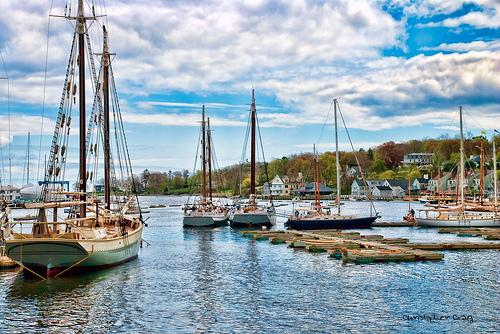Analyze the sentiment evoked by the image, based on the objects and settings in it. The image evokes a sense of peacefulness and tranquility, with calm water in the harbor, boats gently floating or docked, and picturesque houses along the shore. Describe the placement and appearance of the houses along the shore. The houses are scattered along the edge of the shore, some overlooking the boats in the harbor with different colors and styles, one house is white and halfway up a hill. Count the number of boats visible in the image. There are at least seven boats visible in the image. Elaborate on the condition of the sky and water in the picture. The sky has white puffy clouds scattered across a blue backdrop, and the water in the harbor is calm and serene. Provide a brief summary of the most prominent objects in the image. There are multiple boats in the harbor, houses along the shore, a white house on a hill, a wooden dock, and calm water with clouds in the sky. Identify the main landscape features in the scene. In the scene, there is a harbor with calm water, tree-covered hills, houses on the shoreline, and a blue sky with white puffy clouds. Does the image portray a realistic representation of a typical harbor scene, based on the objects and their interactions? Explain. Yes, the image portrays a realistic harbor scene, with different types of boats floating or docked, a wooden pier extending into the water, houses along the shore, and a calm, serene atmosphere. Explain the scene involving the wooden dock and the interaction of objects around it. A wooden dock stretches into the calm harbor water, with a dark colored boat nearby and other boats floating or docked in the vicinity, surrounded by houses along the shore and hills with trees. List the different types of boats that can be seen in the image. Sailboat, boats with no sails, dark colored boat, boat with painted red bottom, and boat with a tall mast. What is the primary activity happening in this picture? Multiple boats are floating in the harbor, some docked at a wooden pier and others sailing on the calm water. Is there a green house on the hill in the image? There is a mention of a white house on a hill but no mention of a green house. Can you see a large red flag on top of one of the boats? There are mentions of masts and boat details, but no mention of a red flag on any boat. Do you see a seagull flying above the water or boats? There are mentions of sky and water details, but no mention of a seagull or any other bird flying above the scene. Can you spot a bridge connecting the shore to one of the docks? There's mention of a wooden dock stretching into the water, but no mention of a bridge connecting it to the shore. Is there a lighthouse present among the buildings along the edge of the shore? There is mention of houses along the edge of the shore, but no mention of a lighthouse. Are there any people visible swimming in the water? No, it's not mentioned in the image. 